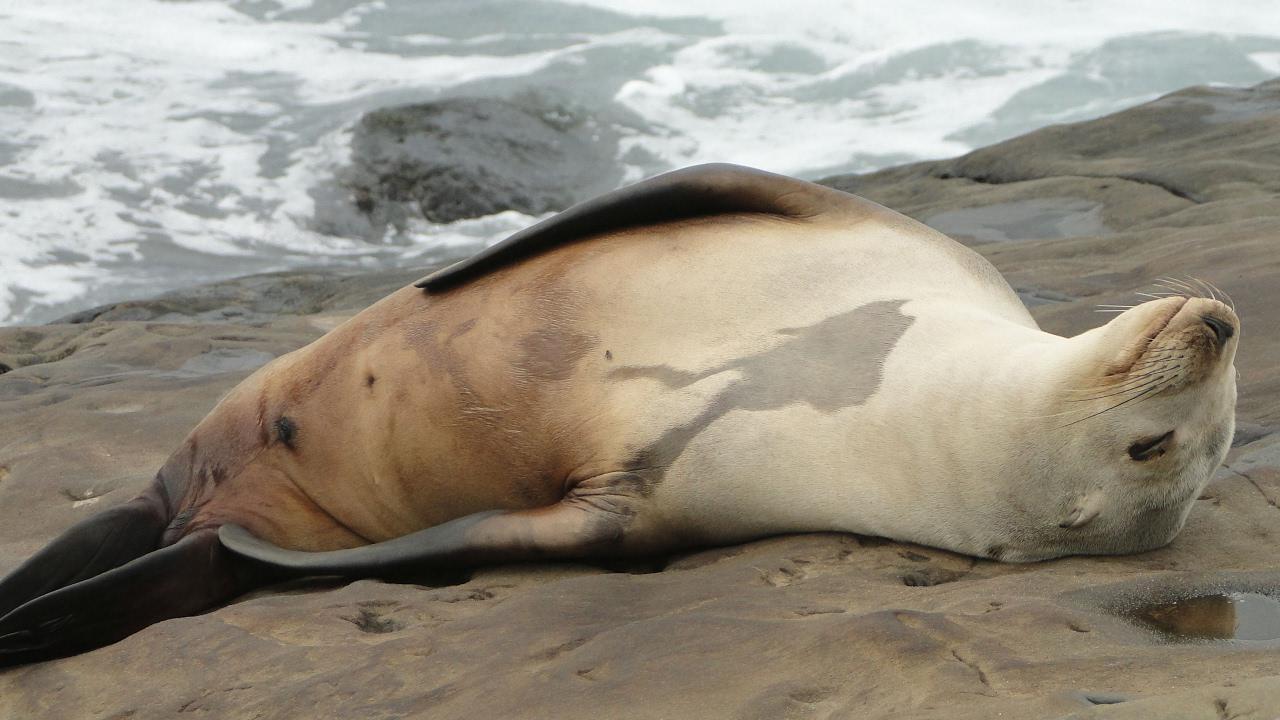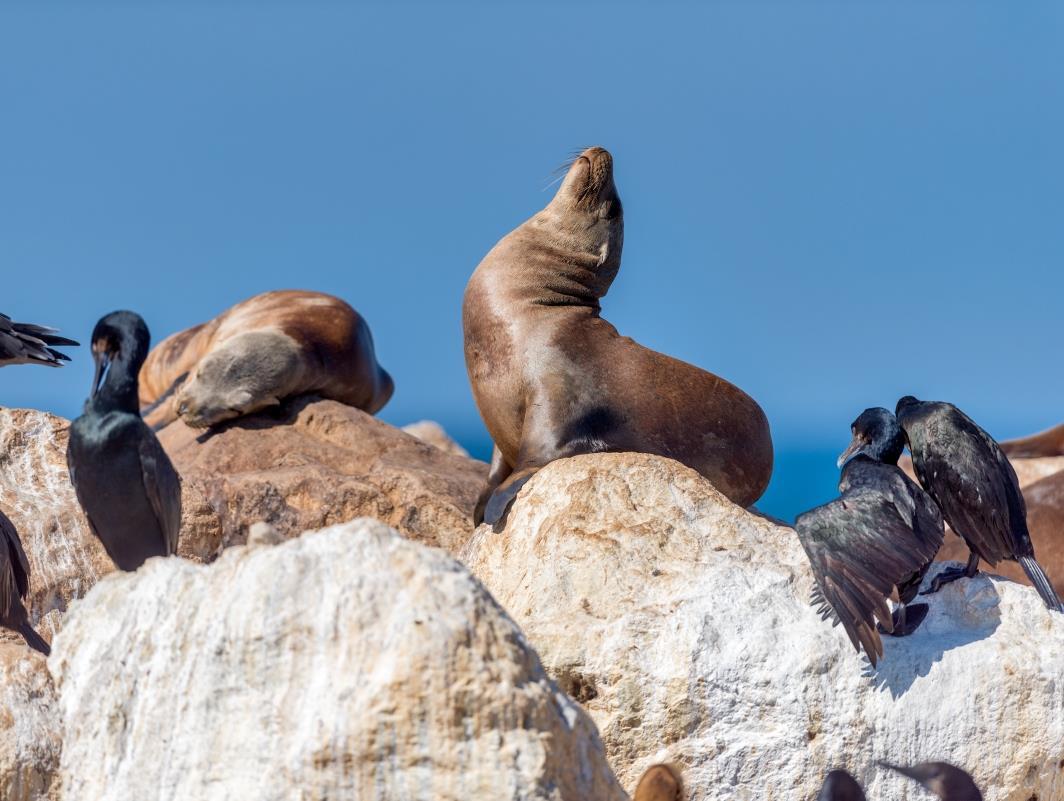The first image is the image on the left, the second image is the image on the right. Considering the images on both sides, is "A tawny-colored seal is sleeping in at least one of the images." valid? Answer yes or no. Yes. The first image is the image on the left, the second image is the image on the right. Assess this claim about the two images: "There are no more than two seals.". Correct or not? Answer yes or no. No. 